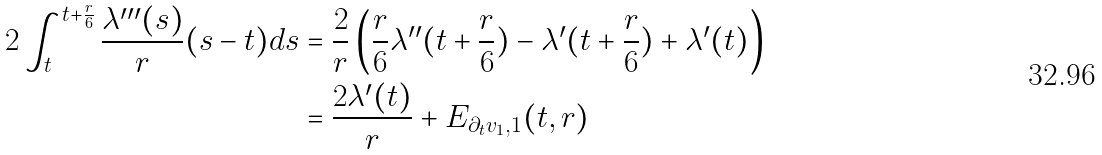Convert formula to latex. <formula><loc_0><loc_0><loc_500><loc_500>2 \int _ { t } ^ { t + \frac { r } { 6 } } \frac { \lambda ^ { \prime \prime \prime } ( s ) } { r } ( s - t ) d s & = \frac { 2 } { r } \left ( \frac { r } { 6 } \lambda ^ { \prime \prime } ( t + \frac { r } { 6 } ) - \lambda ^ { \prime } ( t + \frac { r } { 6 } ) + \lambda ^ { \prime } ( t ) \right ) \\ & = \frac { 2 \lambda ^ { \prime } ( t ) } { r } + E _ { \partial _ { t } v _ { 1 } , 1 } ( t , r )</formula> 